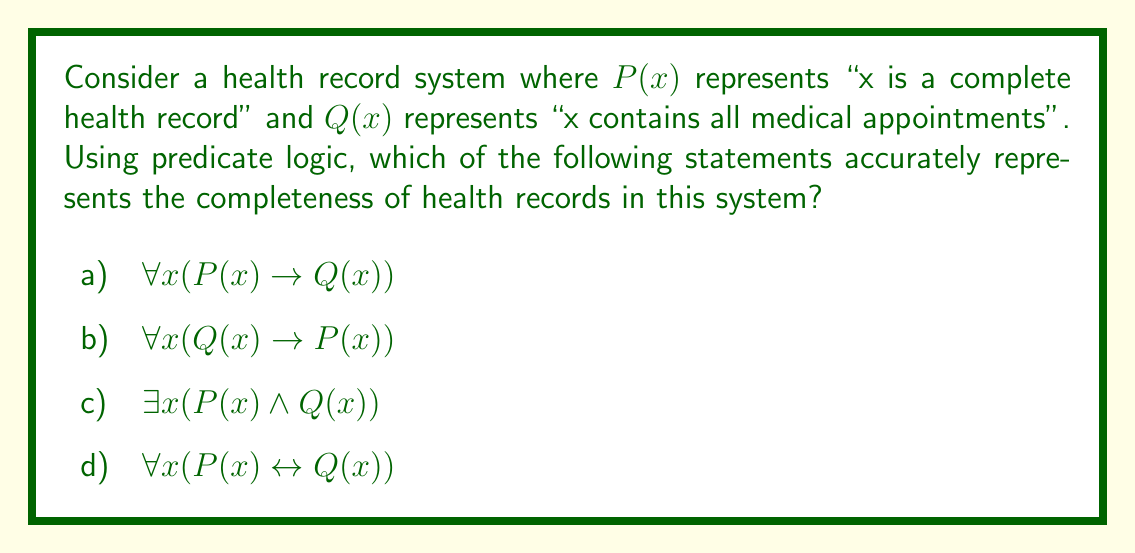Give your solution to this math problem. Let's analyze each option:

a) $\forall x(P(x) \rightarrow Q(x))$
This statement means "For all x, if x is a complete health record, then x contains all medical appointments." This is logically sound, as we would expect a complete health record to include all medical appointments.

b) $\forall x(Q(x) \rightarrow P(x))$
This statement means "For all x, if x contains all medical appointments, then x is a complete health record." This is not necessarily true, as a complete health record may require more information than just medical appointments.

c) $\exists x(P(x) \wedge Q(x))$
This statement means "There exists an x such that x is a complete health record and x contains all medical appointments." While this may be true, it doesn't fully capture the relationship between complete health records and appointment information for all records.

d) $\forall x(P(x) \leftrightarrow Q(x))$
This statement means "For all x, x is a complete health record if and only if x contains all medical appointments." This is too strong, as it implies that containing all medical appointments is the only criterion for a health record to be complete, which is unlikely to be true in practice.

Given the context of a chronic illness patient managing their health records, option (a) provides the most accurate representation. It ensures that all complete health records contain all medical appointments, which is crucial for effective health management.
Answer: a) $\forall x(P(x) \rightarrow Q(x))$ 